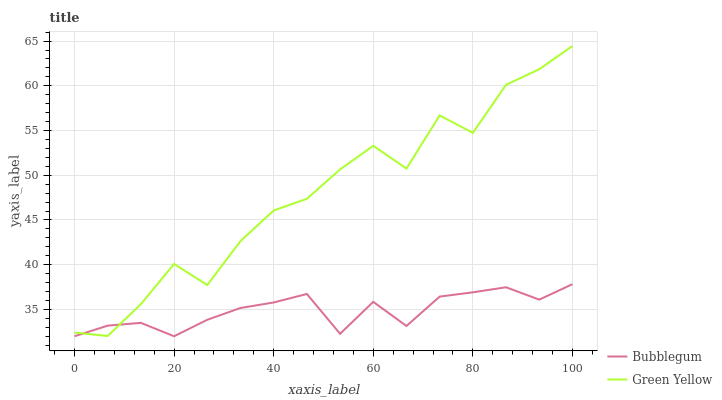Does Bubblegum have the minimum area under the curve?
Answer yes or no. Yes. Does Green Yellow have the maximum area under the curve?
Answer yes or no. Yes. Does Bubblegum have the maximum area under the curve?
Answer yes or no. No. Is Bubblegum the smoothest?
Answer yes or no. Yes. Is Green Yellow the roughest?
Answer yes or no. Yes. Is Bubblegum the roughest?
Answer yes or no. No. Does Bubblegum have the lowest value?
Answer yes or no. Yes. Does Green Yellow have the highest value?
Answer yes or no. Yes. Does Bubblegum have the highest value?
Answer yes or no. No. Does Green Yellow intersect Bubblegum?
Answer yes or no. Yes. Is Green Yellow less than Bubblegum?
Answer yes or no. No. Is Green Yellow greater than Bubblegum?
Answer yes or no. No. 